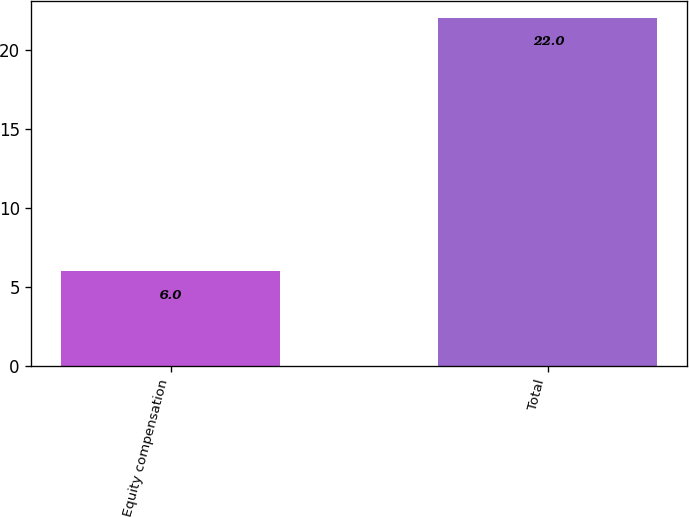Convert chart. <chart><loc_0><loc_0><loc_500><loc_500><bar_chart><fcel>Equity compensation<fcel>Total<nl><fcel>6<fcel>22<nl></chart> 